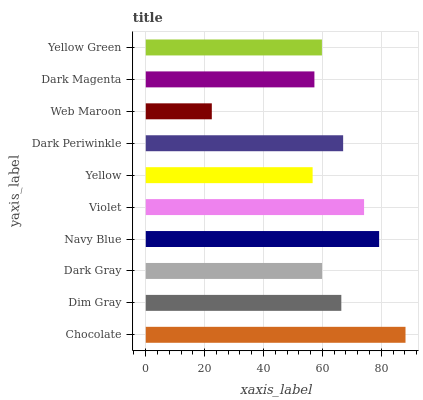Is Web Maroon the minimum?
Answer yes or no. Yes. Is Chocolate the maximum?
Answer yes or no. Yes. Is Dim Gray the minimum?
Answer yes or no. No. Is Dim Gray the maximum?
Answer yes or no. No. Is Chocolate greater than Dim Gray?
Answer yes or no. Yes. Is Dim Gray less than Chocolate?
Answer yes or no. Yes. Is Dim Gray greater than Chocolate?
Answer yes or no. No. Is Chocolate less than Dim Gray?
Answer yes or no. No. Is Dim Gray the high median?
Answer yes or no. Yes. Is Dark Gray the low median?
Answer yes or no. Yes. Is Yellow the high median?
Answer yes or no. No. Is Dark Periwinkle the low median?
Answer yes or no. No. 